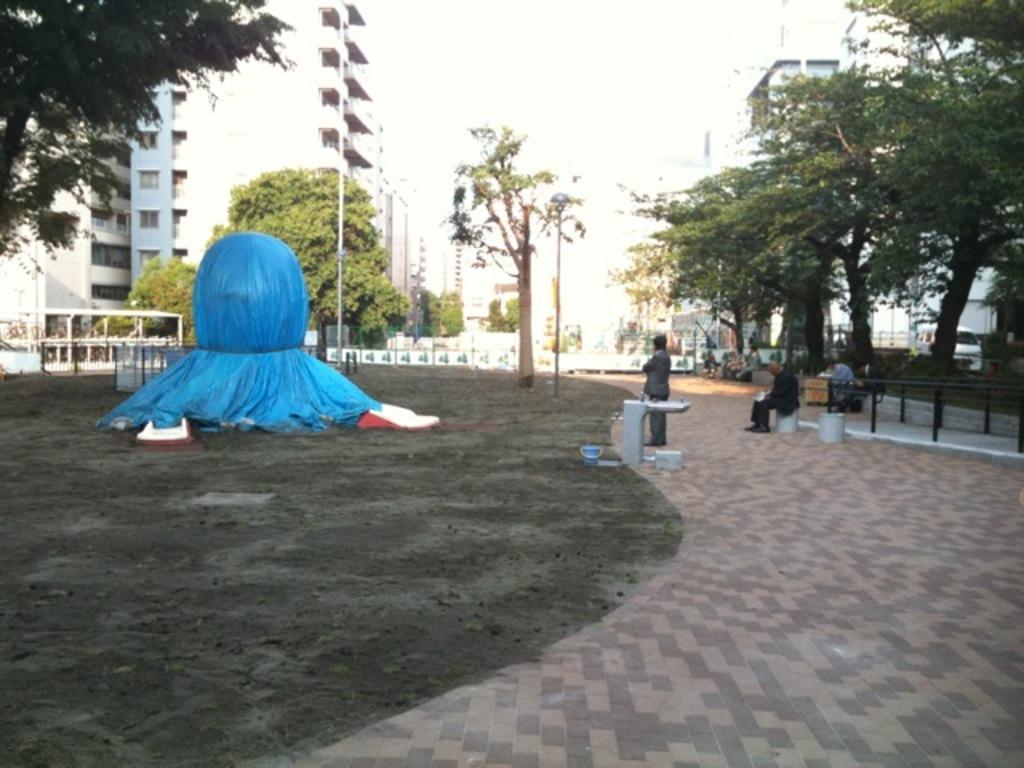Can you describe this image briefly? This picture shows few buildings and trees and we see few people seated and a man standing and we see bucket and and a blue color cover and a pole light. 